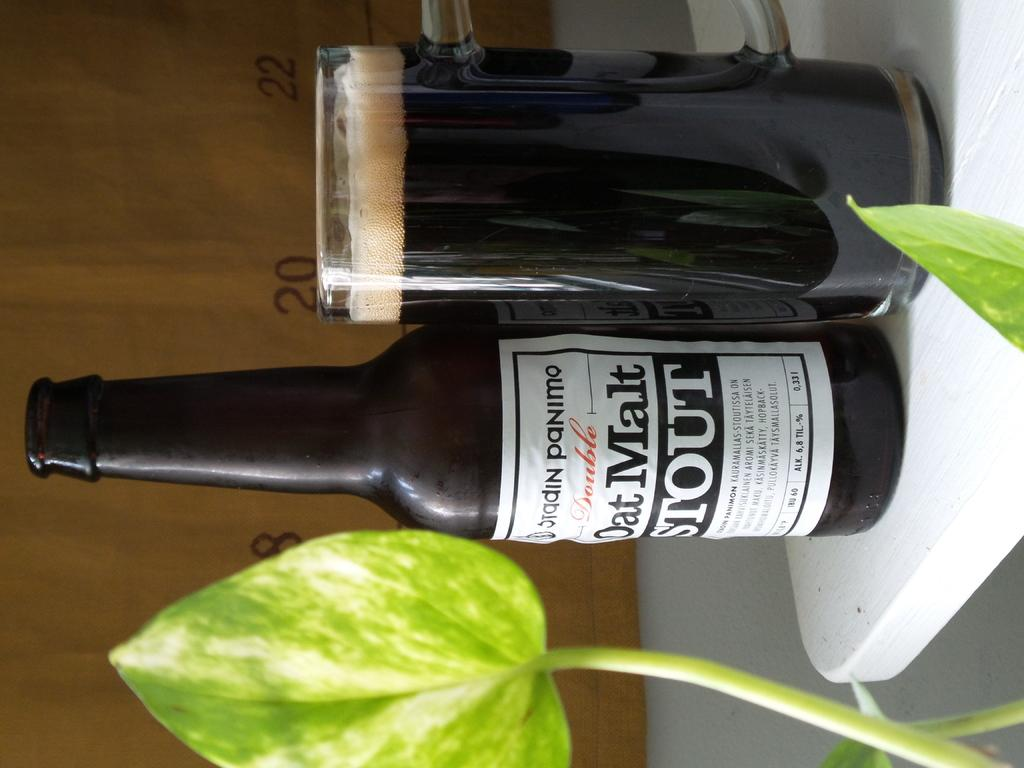<image>
Describe the image concisely. A bottle of Oat Malt stout next to a glass of beer. 